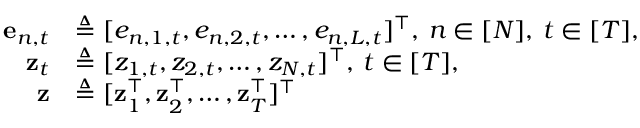Convert formula to latex. <formula><loc_0><loc_0><loc_500><loc_500>\begin{array} { r l } { e _ { n , t } } & { \triangle q [ e _ { n , 1 , t } , e _ { n , 2 , t } , \hdots , e _ { n , L , t } ] ^ { \intercal } , \, n \in [ N ] , \, t \in [ T ] , } \\ { z _ { t } } & { \triangle q [ z _ { 1 , t } , z _ { 2 , t } , \hdots , z _ { N , t } ] ^ { \intercal } , \, t \in [ T ] , } \\ { z } & { \triangle q [ z _ { 1 } ^ { \intercal } , z _ { 2 } ^ { \intercal } , \hdots , z _ { T } ^ { \intercal } ] ^ { \intercal } \, } \end{array}</formula> 